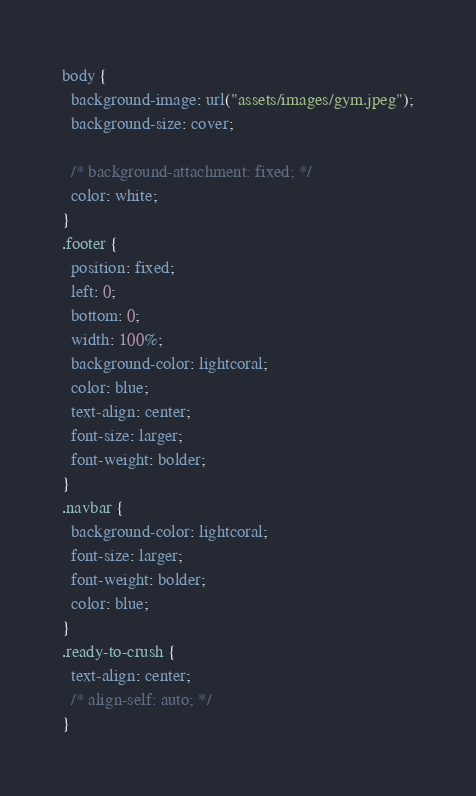<code> <loc_0><loc_0><loc_500><loc_500><_CSS_>body {
  background-image: url("assets/images/gym.jpeg");
  background-size: cover;

  /* background-attachment: fixed; */
  color: white;
}
.footer {
  position: fixed;
  left: 0;
  bottom: 0;
  width: 100%;
  background-color: lightcoral;
  color: blue;
  text-align: center;
  font-size: larger;
  font-weight: bolder;
}
.navbar {
  background-color: lightcoral;
  font-size: larger;
  font-weight: bolder;
  color: blue;
}
.ready-to-crush {
  text-align: center;
  /* align-self: auto; */
}
</code> 